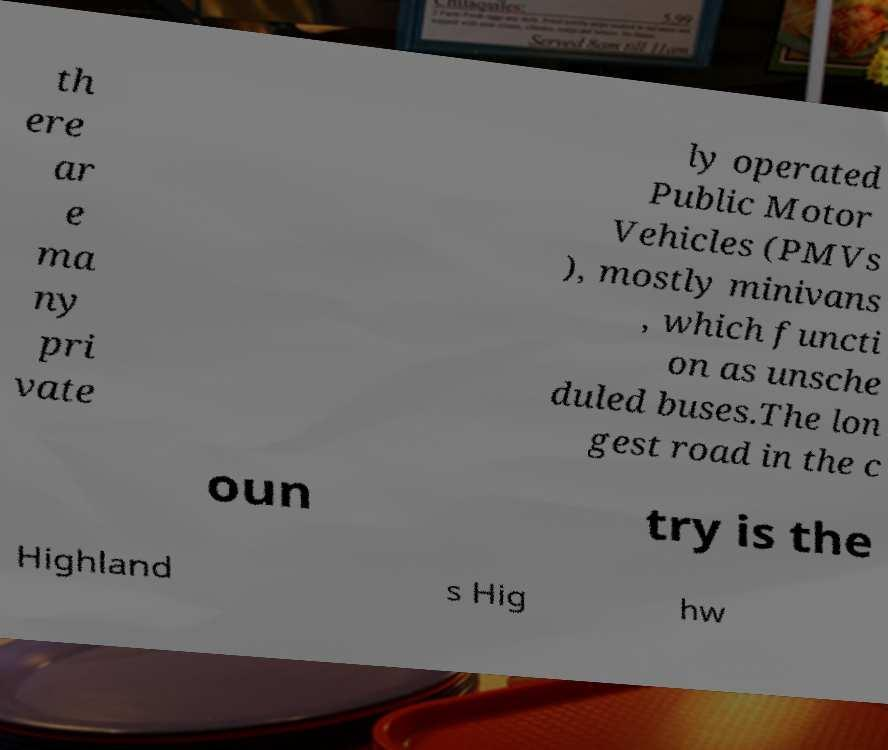Could you assist in decoding the text presented in this image and type it out clearly? th ere ar e ma ny pri vate ly operated Public Motor Vehicles (PMVs ), mostly minivans , which functi on as unsche duled buses.The lon gest road in the c oun try is the Highland s Hig hw 